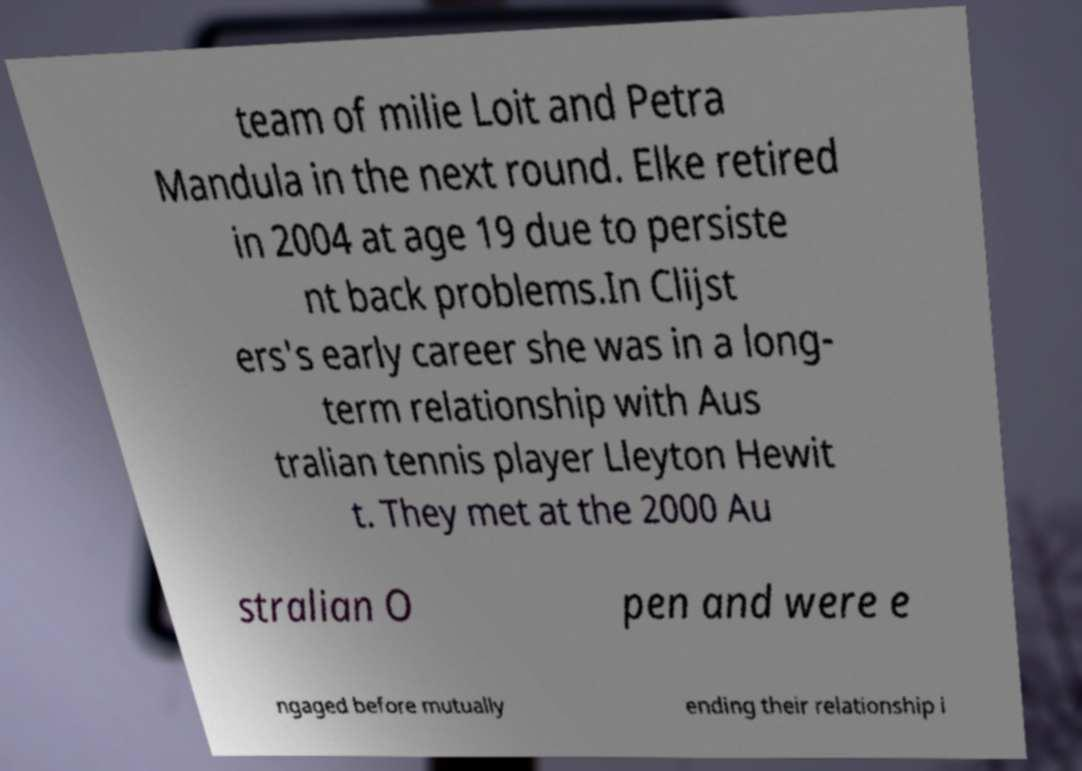What messages or text are displayed in this image? I need them in a readable, typed format. team of milie Loit and Petra Mandula in the next round. Elke retired in 2004 at age 19 due to persiste nt back problems.In Clijst ers's early career she was in a long- term relationship with Aus tralian tennis player Lleyton Hewit t. They met at the 2000 Au stralian O pen and were e ngaged before mutually ending their relationship i 